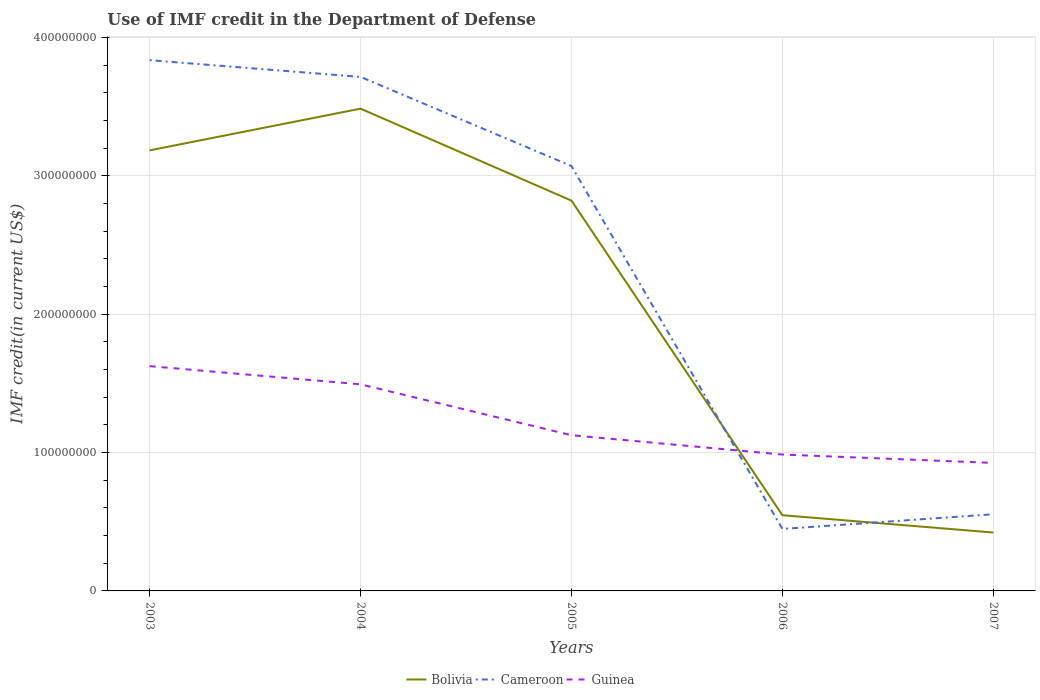How many different coloured lines are there?
Your answer should be compact. 3. Across all years, what is the maximum IMF credit in the Department of Defense in Bolivia?
Ensure brevity in your answer.  4.22e+07. In which year was the IMF credit in the Department of Defense in Guinea maximum?
Keep it short and to the point. 2007. What is the total IMF credit in the Department of Defense in Cameroon in the graph?
Your response must be concise. 2.52e+08. What is the difference between the highest and the second highest IMF credit in the Department of Defense in Guinea?
Keep it short and to the point. 6.99e+07. What is the difference between the highest and the lowest IMF credit in the Department of Defense in Guinea?
Give a very brief answer. 2. How many years are there in the graph?
Make the answer very short. 5. Are the values on the major ticks of Y-axis written in scientific E-notation?
Keep it short and to the point. No. Does the graph contain any zero values?
Provide a succinct answer. No. What is the title of the graph?
Provide a succinct answer. Use of IMF credit in the Department of Defense. Does "Serbia" appear as one of the legend labels in the graph?
Offer a terse response. No. What is the label or title of the Y-axis?
Your answer should be very brief. IMF credit(in current US$). What is the IMF credit(in current US$) of Bolivia in 2003?
Ensure brevity in your answer.  3.18e+08. What is the IMF credit(in current US$) of Cameroon in 2003?
Ensure brevity in your answer.  3.83e+08. What is the IMF credit(in current US$) of Guinea in 2003?
Keep it short and to the point. 1.62e+08. What is the IMF credit(in current US$) in Bolivia in 2004?
Offer a terse response. 3.48e+08. What is the IMF credit(in current US$) of Cameroon in 2004?
Offer a terse response. 3.71e+08. What is the IMF credit(in current US$) in Guinea in 2004?
Give a very brief answer. 1.49e+08. What is the IMF credit(in current US$) of Bolivia in 2005?
Provide a succinct answer. 2.82e+08. What is the IMF credit(in current US$) of Cameroon in 2005?
Provide a short and direct response. 3.07e+08. What is the IMF credit(in current US$) in Guinea in 2005?
Offer a very short reply. 1.13e+08. What is the IMF credit(in current US$) in Bolivia in 2006?
Give a very brief answer. 5.47e+07. What is the IMF credit(in current US$) in Cameroon in 2006?
Your answer should be compact. 4.48e+07. What is the IMF credit(in current US$) in Guinea in 2006?
Offer a terse response. 9.85e+07. What is the IMF credit(in current US$) in Bolivia in 2007?
Provide a succinct answer. 4.22e+07. What is the IMF credit(in current US$) in Cameroon in 2007?
Your answer should be compact. 5.54e+07. What is the IMF credit(in current US$) of Guinea in 2007?
Offer a terse response. 9.25e+07. Across all years, what is the maximum IMF credit(in current US$) of Bolivia?
Provide a succinct answer. 3.48e+08. Across all years, what is the maximum IMF credit(in current US$) of Cameroon?
Your answer should be compact. 3.83e+08. Across all years, what is the maximum IMF credit(in current US$) in Guinea?
Your answer should be compact. 1.62e+08. Across all years, what is the minimum IMF credit(in current US$) of Bolivia?
Keep it short and to the point. 4.22e+07. Across all years, what is the minimum IMF credit(in current US$) in Cameroon?
Provide a succinct answer. 4.48e+07. Across all years, what is the minimum IMF credit(in current US$) in Guinea?
Your answer should be compact. 9.25e+07. What is the total IMF credit(in current US$) in Bolivia in the graph?
Offer a terse response. 1.05e+09. What is the total IMF credit(in current US$) of Cameroon in the graph?
Give a very brief answer. 1.16e+09. What is the total IMF credit(in current US$) in Guinea in the graph?
Offer a very short reply. 6.15e+08. What is the difference between the IMF credit(in current US$) of Bolivia in 2003 and that in 2004?
Provide a succinct answer. -3.01e+07. What is the difference between the IMF credit(in current US$) of Cameroon in 2003 and that in 2004?
Provide a succinct answer. 1.21e+07. What is the difference between the IMF credit(in current US$) of Guinea in 2003 and that in 2004?
Make the answer very short. 1.31e+07. What is the difference between the IMF credit(in current US$) in Bolivia in 2003 and that in 2005?
Keep it short and to the point. 3.63e+07. What is the difference between the IMF credit(in current US$) of Cameroon in 2003 and that in 2005?
Your answer should be compact. 7.65e+07. What is the difference between the IMF credit(in current US$) in Guinea in 2003 and that in 2005?
Offer a terse response. 4.99e+07. What is the difference between the IMF credit(in current US$) of Bolivia in 2003 and that in 2006?
Your answer should be compact. 2.64e+08. What is the difference between the IMF credit(in current US$) in Cameroon in 2003 and that in 2006?
Offer a terse response. 3.39e+08. What is the difference between the IMF credit(in current US$) of Guinea in 2003 and that in 2006?
Ensure brevity in your answer.  6.39e+07. What is the difference between the IMF credit(in current US$) in Bolivia in 2003 and that in 2007?
Your answer should be compact. 2.76e+08. What is the difference between the IMF credit(in current US$) in Cameroon in 2003 and that in 2007?
Keep it short and to the point. 3.28e+08. What is the difference between the IMF credit(in current US$) in Guinea in 2003 and that in 2007?
Your answer should be very brief. 6.99e+07. What is the difference between the IMF credit(in current US$) in Bolivia in 2004 and that in 2005?
Provide a succinct answer. 6.65e+07. What is the difference between the IMF credit(in current US$) of Cameroon in 2004 and that in 2005?
Your response must be concise. 6.44e+07. What is the difference between the IMF credit(in current US$) of Guinea in 2004 and that in 2005?
Make the answer very short. 3.68e+07. What is the difference between the IMF credit(in current US$) of Bolivia in 2004 and that in 2006?
Provide a short and direct response. 2.94e+08. What is the difference between the IMF credit(in current US$) of Cameroon in 2004 and that in 2006?
Keep it short and to the point. 3.27e+08. What is the difference between the IMF credit(in current US$) of Guinea in 2004 and that in 2006?
Provide a short and direct response. 5.07e+07. What is the difference between the IMF credit(in current US$) in Bolivia in 2004 and that in 2007?
Ensure brevity in your answer.  3.06e+08. What is the difference between the IMF credit(in current US$) of Cameroon in 2004 and that in 2007?
Keep it short and to the point. 3.16e+08. What is the difference between the IMF credit(in current US$) in Guinea in 2004 and that in 2007?
Give a very brief answer. 5.68e+07. What is the difference between the IMF credit(in current US$) of Bolivia in 2005 and that in 2006?
Offer a terse response. 2.27e+08. What is the difference between the IMF credit(in current US$) in Cameroon in 2005 and that in 2006?
Make the answer very short. 2.62e+08. What is the difference between the IMF credit(in current US$) of Guinea in 2005 and that in 2006?
Make the answer very short. 1.40e+07. What is the difference between the IMF credit(in current US$) of Bolivia in 2005 and that in 2007?
Provide a short and direct response. 2.40e+08. What is the difference between the IMF credit(in current US$) of Cameroon in 2005 and that in 2007?
Your response must be concise. 2.52e+08. What is the difference between the IMF credit(in current US$) of Guinea in 2005 and that in 2007?
Provide a short and direct response. 2.00e+07. What is the difference between the IMF credit(in current US$) in Bolivia in 2006 and that in 2007?
Make the answer very short. 1.25e+07. What is the difference between the IMF credit(in current US$) in Cameroon in 2006 and that in 2007?
Give a very brief answer. -1.06e+07. What is the difference between the IMF credit(in current US$) of Guinea in 2006 and that in 2007?
Ensure brevity in your answer.  6.04e+06. What is the difference between the IMF credit(in current US$) in Bolivia in 2003 and the IMF credit(in current US$) in Cameroon in 2004?
Your response must be concise. -5.31e+07. What is the difference between the IMF credit(in current US$) in Bolivia in 2003 and the IMF credit(in current US$) in Guinea in 2004?
Give a very brief answer. 1.69e+08. What is the difference between the IMF credit(in current US$) of Cameroon in 2003 and the IMF credit(in current US$) of Guinea in 2004?
Your answer should be very brief. 2.34e+08. What is the difference between the IMF credit(in current US$) in Bolivia in 2003 and the IMF credit(in current US$) in Cameroon in 2005?
Your response must be concise. 1.14e+07. What is the difference between the IMF credit(in current US$) in Bolivia in 2003 and the IMF credit(in current US$) in Guinea in 2005?
Your response must be concise. 2.06e+08. What is the difference between the IMF credit(in current US$) in Cameroon in 2003 and the IMF credit(in current US$) in Guinea in 2005?
Your answer should be very brief. 2.71e+08. What is the difference between the IMF credit(in current US$) of Bolivia in 2003 and the IMF credit(in current US$) of Cameroon in 2006?
Keep it short and to the point. 2.74e+08. What is the difference between the IMF credit(in current US$) in Bolivia in 2003 and the IMF credit(in current US$) in Guinea in 2006?
Ensure brevity in your answer.  2.20e+08. What is the difference between the IMF credit(in current US$) in Cameroon in 2003 and the IMF credit(in current US$) in Guinea in 2006?
Your answer should be compact. 2.85e+08. What is the difference between the IMF credit(in current US$) in Bolivia in 2003 and the IMF credit(in current US$) in Cameroon in 2007?
Your answer should be very brief. 2.63e+08. What is the difference between the IMF credit(in current US$) of Bolivia in 2003 and the IMF credit(in current US$) of Guinea in 2007?
Your answer should be very brief. 2.26e+08. What is the difference between the IMF credit(in current US$) of Cameroon in 2003 and the IMF credit(in current US$) of Guinea in 2007?
Offer a terse response. 2.91e+08. What is the difference between the IMF credit(in current US$) in Bolivia in 2004 and the IMF credit(in current US$) in Cameroon in 2005?
Ensure brevity in your answer.  4.15e+07. What is the difference between the IMF credit(in current US$) in Bolivia in 2004 and the IMF credit(in current US$) in Guinea in 2005?
Provide a short and direct response. 2.36e+08. What is the difference between the IMF credit(in current US$) in Cameroon in 2004 and the IMF credit(in current US$) in Guinea in 2005?
Give a very brief answer. 2.59e+08. What is the difference between the IMF credit(in current US$) in Bolivia in 2004 and the IMF credit(in current US$) in Cameroon in 2006?
Make the answer very short. 3.04e+08. What is the difference between the IMF credit(in current US$) in Bolivia in 2004 and the IMF credit(in current US$) in Guinea in 2006?
Provide a short and direct response. 2.50e+08. What is the difference between the IMF credit(in current US$) of Cameroon in 2004 and the IMF credit(in current US$) of Guinea in 2006?
Your response must be concise. 2.73e+08. What is the difference between the IMF credit(in current US$) in Bolivia in 2004 and the IMF credit(in current US$) in Cameroon in 2007?
Offer a terse response. 2.93e+08. What is the difference between the IMF credit(in current US$) of Bolivia in 2004 and the IMF credit(in current US$) of Guinea in 2007?
Ensure brevity in your answer.  2.56e+08. What is the difference between the IMF credit(in current US$) of Cameroon in 2004 and the IMF credit(in current US$) of Guinea in 2007?
Offer a very short reply. 2.79e+08. What is the difference between the IMF credit(in current US$) in Bolivia in 2005 and the IMF credit(in current US$) in Cameroon in 2006?
Give a very brief answer. 2.37e+08. What is the difference between the IMF credit(in current US$) in Bolivia in 2005 and the IMF credit(in current US$) in Guinea in 2006?
Give a very brief answer. 1.83e+08. What is the difference between the IMF credit(in current US$) in Cameroon in 2005 and the IMF credit(in current US$) in Guinea in 2006?
Offer a terse response. 2.08e+08. What is the difference between the IMF credit(in current US$) of Bolivia in 2005 and the IMF credit(in current US$) of Cameroon in 2007?
Give a very brief answer. 2.27e+08. What is the difference between the IMF credit(in current US$) of Bolivia in 2005 and the IMF credit(in current US$) of Guinea in 2007?
Your response must be concise. 1.89e+08. What is the difference between the IMF credit(in current US$) in Cameroon in 2005 and the IMF credit(in current US$) in Guinea in 2007?
Offer a terse response. 2.14e+08. What is the difference between the IMF credit(in current US$) of Bolivia in 2006 and the IMF credit(in current US$) of Cameroon in 2007?
Keep it short and to the point. -7.03e+05. What is the difference between the IMF credit(in current US$) of Bolivia in 2006 and the IMF credit(in current US$) of Guinea in 2007?
Offer a terse response. -3.78e+07. What is the difference between the IMF credit(in current US$) in Cameroon in 2006 and the IMF credit(in current US$) in Guinea in 2007?
Make the answer very short. -4.77e+07. What is the average IMF credit(in current US$) in Bolivia per year?
Your answer should be compact. 2.09e+08. What is the average IMF credit(in current US$) of Cameroon per year?
Offer a terse response. 2.32e+08. What is the average IMF credit(in current US$) in Guinea per year?
Your response must be concise. 1.23e+08. In the year 2003, what is the difference between the IMF credit(in current US$) in Bolivia and IMF credit(in current US$) in Cameroon?
Your answer should be compact. -6.51e+07. In the year 2003, what is the difference between the IMF credit(in current US$) in Bolivia and IMF credit(in current US$) in Guinea?
Make the answer very short. 1.56e+08. In the year 2003, what is the difference between the IMF credit(in current US$) in Cameroon and IMF credit(in current US$) in Guinea?
Keep it short and to the point. 2.21e+08. In the year 2004, what is the difference between the IMF credit(in current US$) in Bolivia and IMF credit(in current US$) in Cameroon?
Provide a succinct answer. -2.29e+07. In the year 2004, what is the difference between the IMF credit(in current US$) in Bolivia and IMF credit(in current US$) in Guinea?
Offer a very short reply. 1.99e+08. In the year 2004, what is the difference between the IMF credit(in current US$) in Cameroon and IMF credit(in current US$) in Guinea?
Give a very brief answer. 2.22e+08. In the year 2005, what is the difference between the IMF credit(in current US$) of Bolivia and IMF credit(in current US$) of Cameroon?
Provide a short and direct response. -2.50e+07. In the year 2005, what is the difference between the IMF credit(in current US$) of Bolivia and IMF credit(in current US$) of Guinea?
Provide a succinct answer. 1.69e+08. In the year 2005, what is the difference between the IMF credit(in current US$) of Cameroon and IMF credit(in current US$) of Guinea?
Your response must be concise. 1.94e+08. In the year 2006, what is the difference between the IMF credit(in current US$) of Bolivia and IMF credit(in current US$) of Cameroon?
Ensure brevity in your answer.  9.93e+06. In the year 2006, what is the difference between the IMF credit(in current US$) of Bolivia and IMF credit(in current US$) of Guinea?
Provide a short and direct response. -4.38e+07. In the year 2006, what is the difference between the IMF credit(in current US$) in Cameroon and IMF credit(in current US$) in Guinea?
Your answer should be very brief. -5.38e+07. In the year 2007, what is the difference between the IMF credit(in current US$) in Bolivia and IMF credit(in current US$) in Cameroon?
Make the answer very short. -1.32e+07. In the year 2007, what is the difference between the IMF credit(in current US$) in Bolivia and IMF credit(in current US$) in Guinea?
Give a very brief answer. -5.03e+07. In the year 2007, what is the difference between the IMF credit(in current US$) of Cameroon and IMF credit(in current US$) of Guinea?
Keep it short and to the point. -3.71e+07. What is the ratio of the IMF credit(in current US$) in Bolivia in 2003 to that in 2004?
Offer a terse response. 0.91. What is the ratio of the IMF credit(in current US$) in Cameroon in 2003 to that in 2004?
Offer a terse response. 1.03. What is the ratio of the IMF credit(in current US$) of Guinea in 2003 to that in 2004?
Offer a terse response. 1.09. What is the ratio of the IMF credit(in current US$) in Bolivia in 2003 to that in 2005?
Ensure brevity in your answer.  1.13. What is the ratio of the IMF credit(in current US$) of Cameroon in 2003 to that in 2005?
Offer a terse response. 1.25. What is the ratio of the IMF credit(in current US$) in Guinea in 2003 to that in 2005?
Your response must be concise. 1.44. What is the ratio of the IMF credit(in current US$) of Bolivia in 2003 to that in 2006?
Your answer should be compact. 5.82. What is the ratio of the IMF credit(in current US$) of Cameroon in 2003 to that in 2006?
Give a very brief answer. 8.56. What is the ratio of the IMF credit(in current US$) of Guinea in 2003 to that in 2006?
Offer a terse response. 1.65. What is the ratio of the IMF credit(in current US$) in Bolivia in 2003 to that in 2007?
Provide a succinct answer. 7.54. What is the ratio of the IMF credit(in current US$) of Cameroon in 2003 to that in 2007?
Your response must be concise. 6.92. What is the ratio of the IMF credit(in current US$) of Guinea in 2003 to that in 2007?
Give a very brief answer. 1.76. What is the ratio of the IMF credit(in current US$) of Bolivia in 2004 to that in 2005?
Offer a terse response. 1.24. What is the ratio of the IMF credit(in current US$) of Cameroon in 2004 to that in 2005?
Give a very brief answer. 1.21. What is the ratio of the IMF credit(in current US$) in Guinea in 2004 to that in 2005?
Provide a succinct answer. 1.33. What is the ratio of the IMF credit(in current US$) of Bolivia in 2004 to that in 2006?
Make the answer very short. 6.37. What is the ratio of the IMF credit(in current US$) of Cameroon in 2004 to that in 2006?
Give a very brief answer. 8.29. What is the ratio of the IMF credit(in current US$) of Guinea in 2004 to that in 2006?
Give a very brief answer. 1.51. What is the ratio of the IMF credit(in current US$) of Bolivia in 2004 to that in 2007?
Provide a succinct answer. 8.26. What is the ratio of the IMF credit(in current US$) of Cameroon in 2004 to that in 2007?
Give a very brief answer. 6.7. What is the ratio of the IMF credit(in current US$) in Guinea in 2004 to that in 2007?
Offer a very short reply. 1.61. What is the ratio of the IMF credit(in current US$) in Bolivia in 2005 to that in 2006?
Make the answer very short. 5.15. What is the ratio of the IMF credit(in current US$) of Cameroon in 2005 to that in 2006?
Your answer should be compact. 6.86. What is the ratio of the IMF credit(in current US$) of Guinea in 2005 to that in 2006?
Make the answer very short. 1.14. What is the ratio of the IMF credit(in current US$) in Bolivia in 2005 to that in 2007?
Offer a terse response. 6.68. What is the ratio of the IMF credit(in current US$) of Cameroon in 2005 to that in 2007?
Give a very brief answer. 5.54. What is the ratio of the IMF credit(in current US$) of Guinea in 2005 to that in 2007?
Offer a terse response. 1.22. What is the ratio of the IMF credit(in current US$) of Bolivia in 2006 to that in 2007?
Offer a terse response. 1.3. What is the ratio of the IMF credit(in current US$) of Cameroon in 2006 to that in 2007?
Provide a short and direct response. 0.81. What is the ratio of the IMF credit(in current US$) of Guinea in 2006 to that in 2007?
Ensure brevity in your answer.  1.07. What is the difference between the highest and the second highest IMF credit(in current US$) in Bolivia?
Provide a succinct answer. 3.01e+07. What is the difference between the highest and the second highest IMF credit(in current US$) of Cameroon?
Your response must be concise. 1.21e+07. What is the difference between the highest and the second highest IMF credit(in current US$) in Guinea?
Ensure brevity in your answer.  1.31e+07. What is the difference between the highest and the lowest IMF credit(in current US$) of Bolivia?
Your answer should be very brief. 3.06e+08. What is the difference between the highest and the lowest IMF credit(in current US$) in Cameroon?
Give a very brief answer. 3.39e+08. What is the difference between the highest and the lowest IMF credit(in current US$) of Guinea?
Your answer should be very brief. 6.99e+07. 